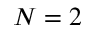Convert formula to latex. <formula><loc_0><loc_0><loc_500><loc_500>N = 2</formula> 